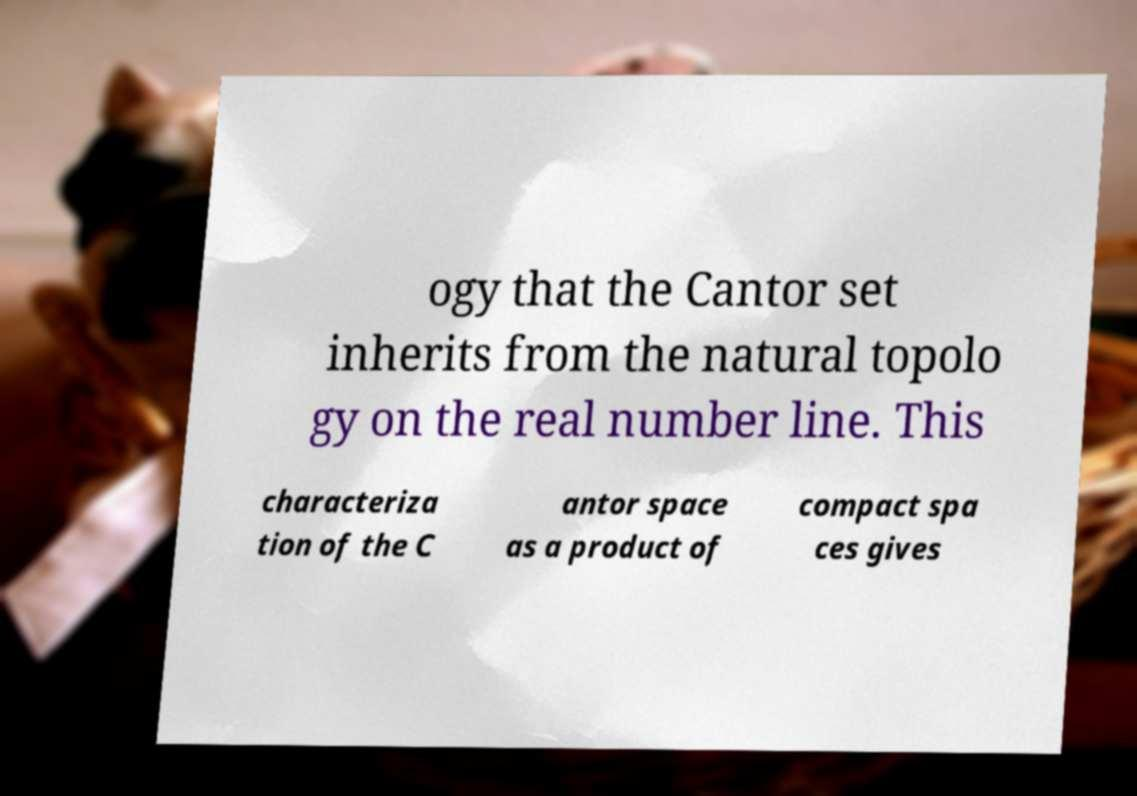There's text embedded in this image that I need extracted. Can you transcribe it verbatim? ogy that the Cantor set inherits from the natural topolo gy on the real number line. This characteriza tion of the C antor space as a product of compact spa ces gives 